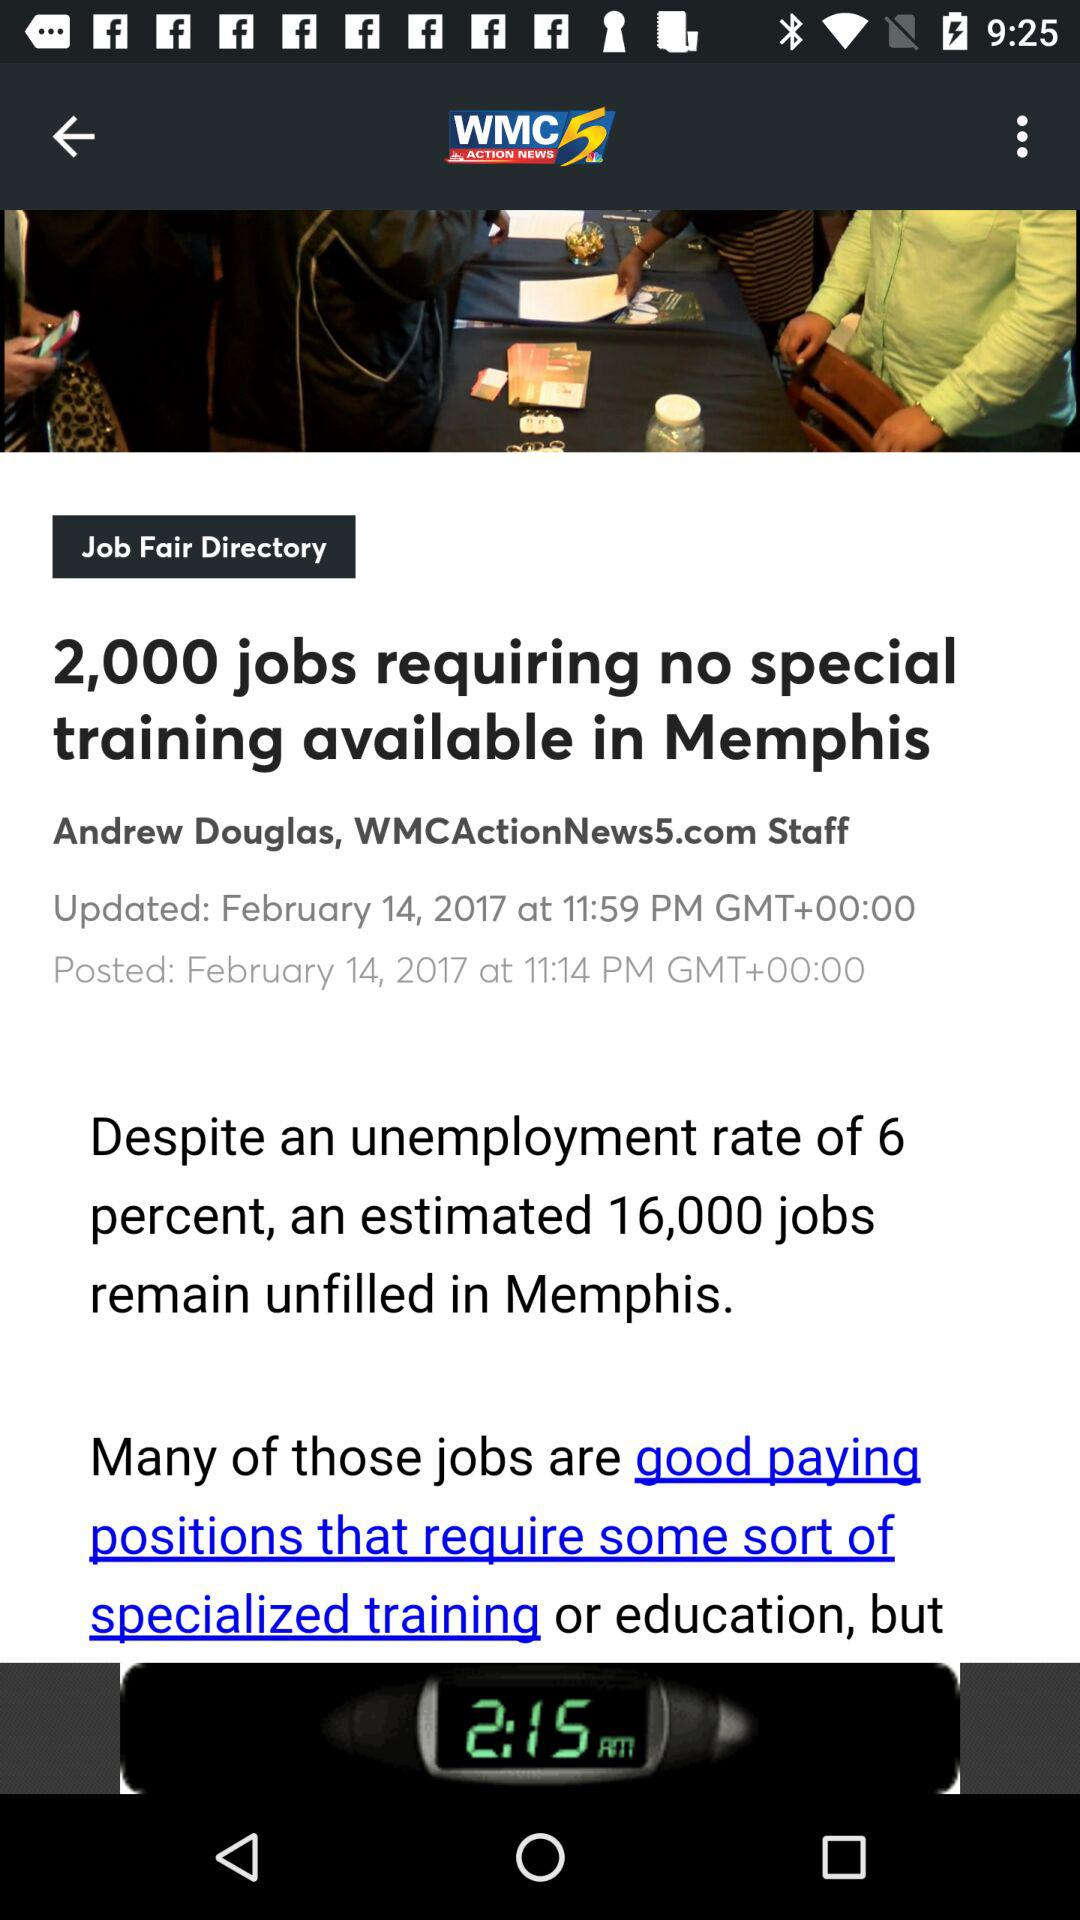What is the unemployment rate in Memphis? The unemployment rate in Memphis is 6%. 